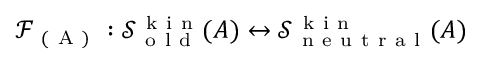<formula> <loc_0><loc_0><loc_500><loc_500>\mathcal { F } _ { ( A ) } \colon \mathcal { S } _ { o l d } ^ { k i n } ( A ) \leftrightarrow \mathcal { S } _ { n e u t r a l } ^ { k i n } ( A )</formula> 